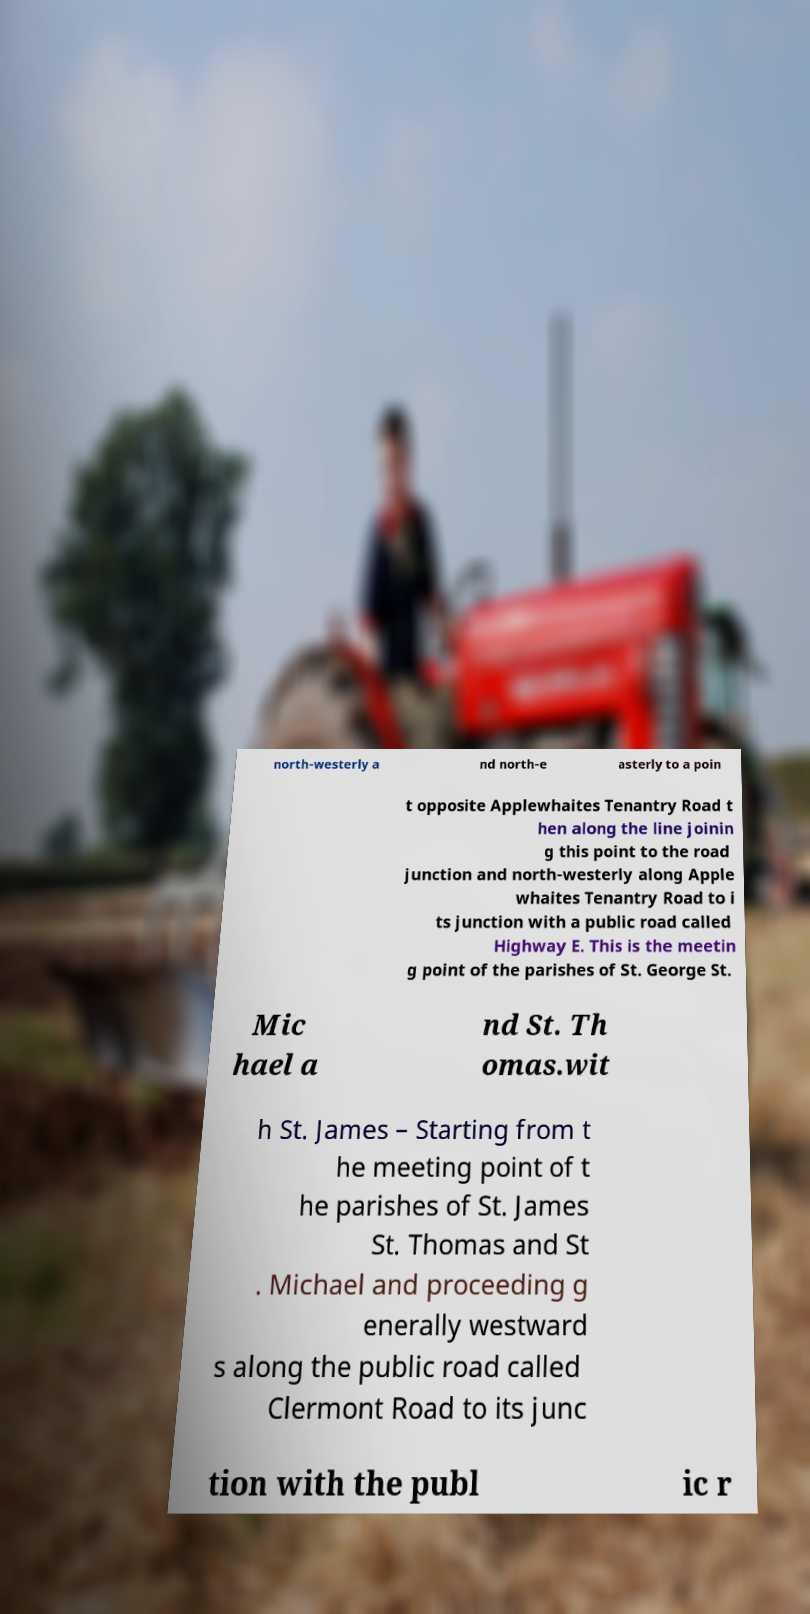Could you extract and type out the text from this image? north-westerly a nd north-e asterly to a poin t opposite Applewhaites Tenantry Road t hen along the line joinin g this point to the road junction and north-westerly along Apple whaites Tenantry Road to i ts junction with a public road called Highway E. This is the meetin g point of the parishes of St. George St. Mic hael a nd St. Th omas.wit h St. James – Starting from t he meeting point of t he parishes of St. James St. Thomas and St . Michael and proceeding g enerally westward s along the public road called Clermont Road to its junc tion with the publ ic r 